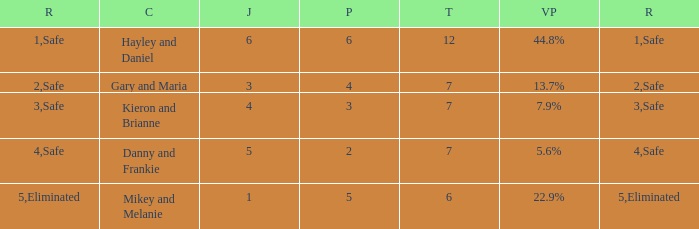What was the result for the total of 12? Safe. 